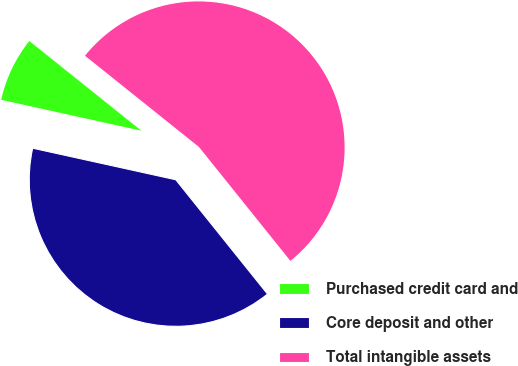Convert chart. <chart><loc_0><loc_0><loc_500><loc_500><pie_chart><fcel>Purchased credit card and<fcel>Core deposit and other<fcel>Total intangible assets<nl><fcel>7.29%<fcel>39.22%<fcel>53.49%<nl></chart> 